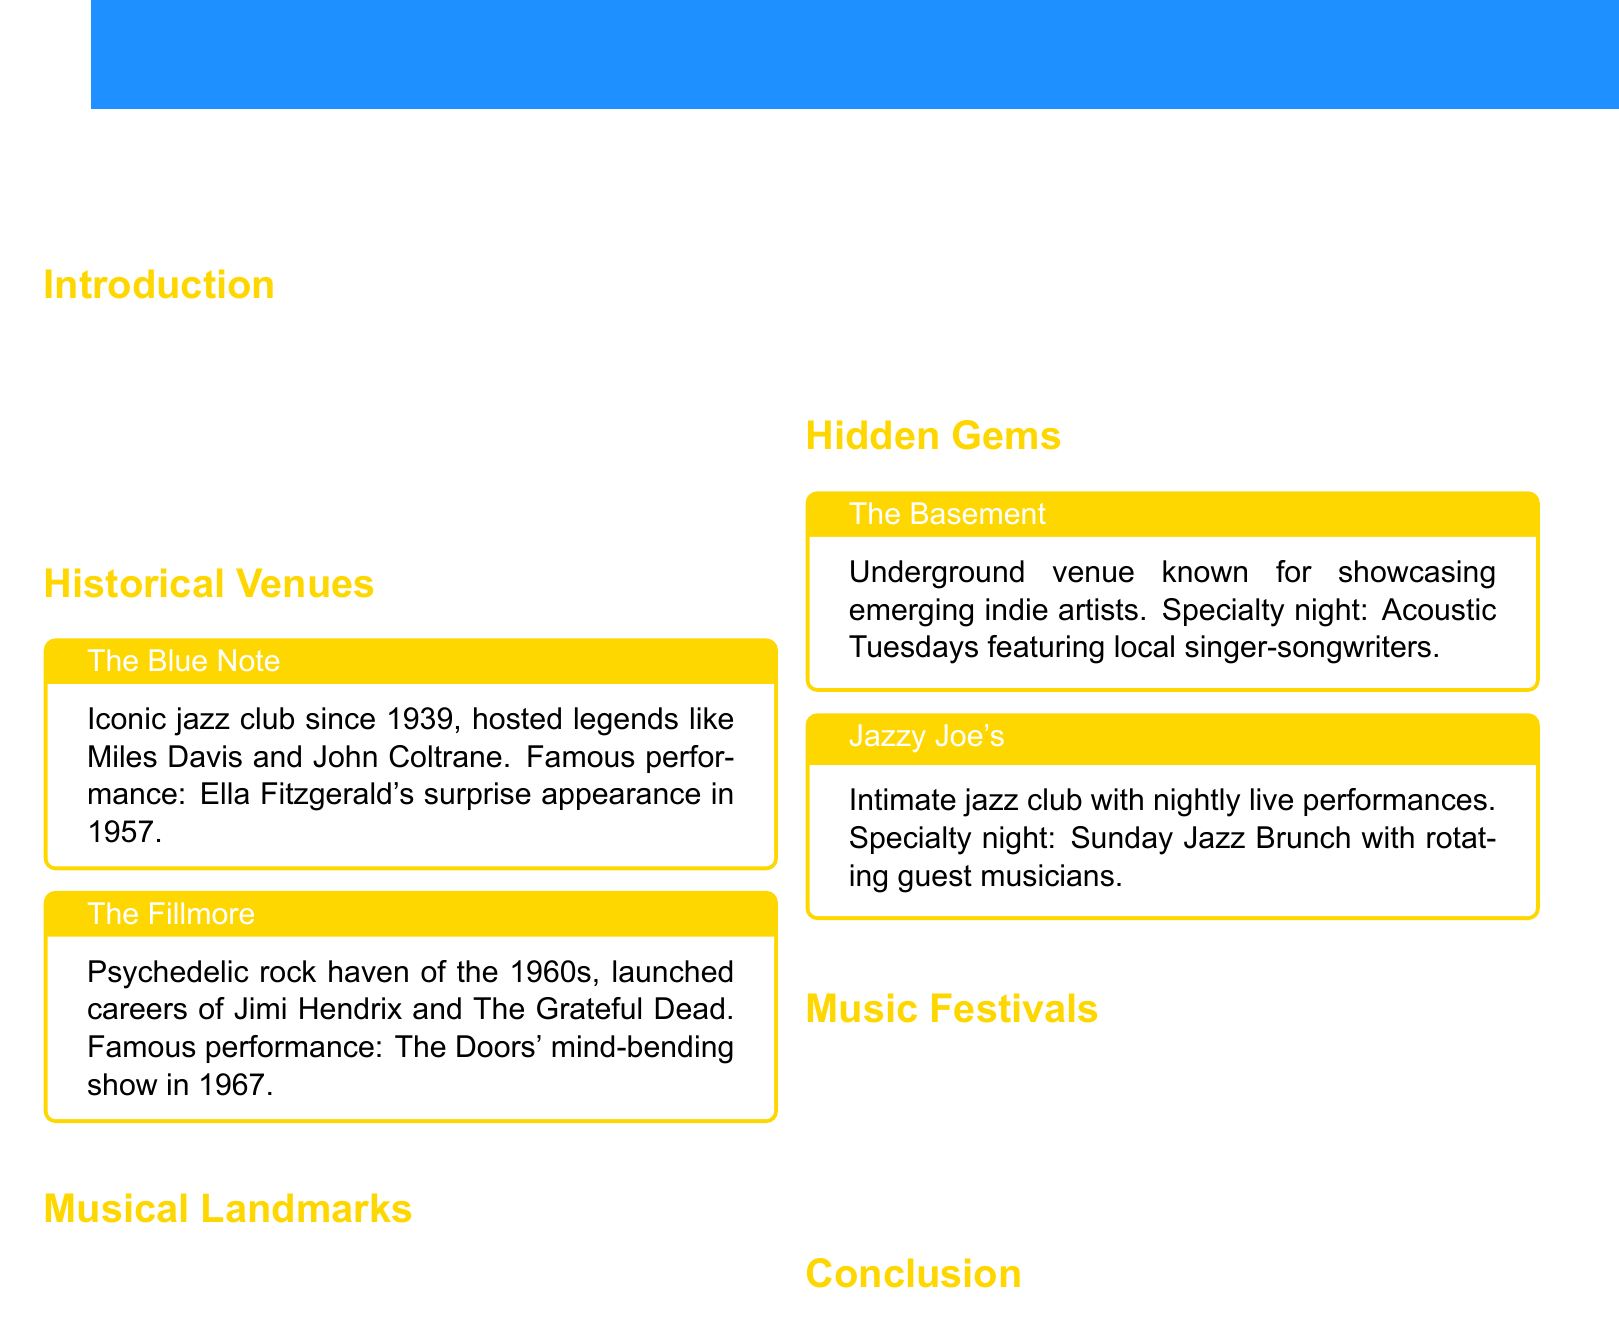what is the name of the iconic jazz club mentioned? The document highlights "The Blue Note" as an iconic jazz club.
Answer: The Blue Note when was The Fillmore established? The document does not specify the establishment year but highlights its significance in the 1960s.
Answer: 1960s who recorded their famous live album at the Apollo Theater? The document states that James Brown recorded his famous live album at the Apollo Theater.
Answer: James Brown what is the specialty night at The Basement? The document mentions "Acoustic Tuesdays" as the specialty night at The Basement.
Answer: Acoustic Tuesdays which annual festival celebrates local and international music? The document refers to the "City Sounds Festival" as the annual music celebration.
Answer: City Sounds Festival what notable acts performed at the City Sounds Festival? The document lists Arcade Fire, Kendrick Lamar, and Florence + The Machine as notable acts.
Answer: Arcade Fire, Kendrick Lamar, Florence + The Machine which hidden gem is known for showcasing indie artists? The Basement is described as an underground venue for emerging indie artists.
Answer: The Basement what fun fact is associated with Strawberry Fields? The document mentions that Strawberry Fields features a mosaic donated by the city of Naples, Italy.
Answer: Mosaic donated by Naples, Italy what is the theme of Jazzy Joe's Sunday event? The document indicates that Jazzy Joe's has a "Sunday Jazz Brunch" featuring guest musicians.
Answer: Sunday Jazz Brunch 